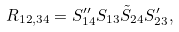<formula> <loc_0><loc_0><loc_500><loc_500>R _ { 1 2 , 3 4 } = S ^ { \prime \prime } _ { 1 4 } S _ { 1 3 } \tilde { S } _ { 2 4 } S ^ { \prime } _ { 2 3 } ,</formula> 